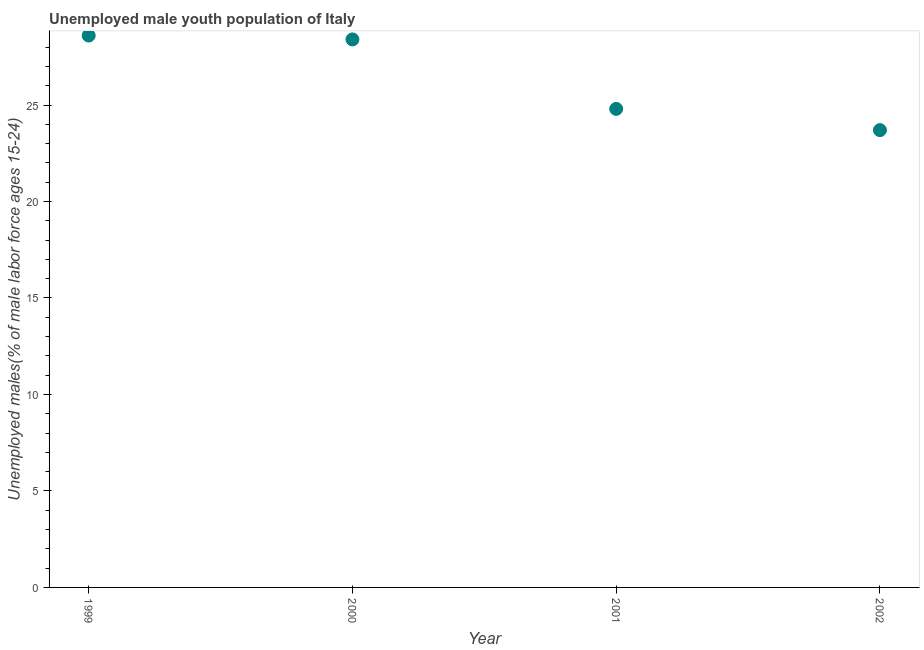What is the unemployed male youth in 2002?
Your answer should be very brief. 23.7. Across all years, what is the maximum unemployed male youth?
Your response must be concise. 28.6. Across all years, what is the minimum unemployed male youth?
Provide a succinct answer. 23.7. In which year was the unemployed male youth minimum?
Offer a terse response. 2002. What is the sum of the unemployed male youth?
Make the answer very short. 105.5. What is the difference between the unemployed male youth in 1999 and 2002?
Provide a succinct answer. 4.9. What is the average unemployed male youth per year?
Provide a succinct answer. 26.38. What is the median unemployed male youth?
Offer a very short reply. 26.6. Do a majority of the years between 1999 and 2000 (inclusive) have unemployed male youth greater than 25 %?
Give a very brief answer. Yes. What is the ratio of the unemployed male youth in 1999 to that in 2001?
Keep it short and to the point. 1.15. Is the unemployed male youth in 2000 less than that in 2002?
Provide a succinct answer. No. What is the difference between the highest and the second highest unemployed male youth?
Your response must be concise. 0.2. What is the difference between the highest and the lowest unemployed male youth?
Ensure brevity in your answer.  4.9. In how many years, is the unemployed male youth greater than the average unemployed male youth taken over all years?
Offer a very short reply. 2. How many dotlines are there?
Provide a succinct answer. 1. What is the difference between two consecutive major ticks on the Y-axis?
Your answer should be very brief. 5. Does the graph contain grids?
Provide a short and direct response. No. What is the title of the graph?
Provide a short and direct response. Unemployed male youth population of Italy. What is the label or title of the Y-axis?
Keep it short and to the point. Unemployed males(% of male labor force ages 15-24). What is the Unemployed males(% of male labor force ages 15-24) in 1999?
Your response must be concise. 28.6. What is the Unemployed males(% of male labor force ages 15-24) in 2000?
Your response must be concise. 28.4. What is the Unemployed males(% of male labor force ages 15-24) in 2001?
Give a very brief answer. 24.8. What is the Unemployed males(% of male labor force ages 15-24) in 2002?
Your response must be concise. 23.7. What is the difference between the Unemployed males(% of male labor force ages 15-24) in 1999 and 2002?
Ensure brevity in your answer.  4.9. What is the difference between the Unemployed males(% of male labor force ages 15-24) in 2001 and 2002?
Make the answer very short. 1.1. What is the ratio of the Unemployed males(% of male labor force ages 15-24) in 1999 to that in 2000?
Give a very brief answer. 1.01. What is the ratio of the Unemployed males(% of male labor force ages 15-24) in 1999 to that in 2001?
Ensure brevity in your answer.  1.15. What is the ratio of the Unemployed males(% of male labor force ages 15-24) in 1999 to that in 2002?
Your answer should be compact. 1.21. What is the ratio of the Unemployed males(% of male labor force ages 15-24) in 2000 to that in 2001?
Make the answer very short. 1.15. What is the ratio of the Unemployed males(% of male labor force ages 15-24) in 2000 to that in 2002?
Provide a succinct answer. 1.2. What is the ratio of the Unemployed males(% of male labor force ages 15-24) in 2001 to that in 2002?
Ensure brevity in your answer.  1.05. 